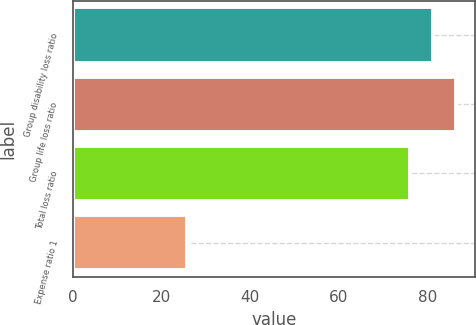Convert chart. <chart><loc_0><loc_0><loc_500><loc_500><bar_chart><fcel>Group disability loss ratio<fcel>Group life loss ratio<fcel>Total loss ratio<fcel>Expense ratio 1<nl><fcel>81.2<fcel>86.3<fcel>76.1<fcel>25.7<nl></chart> 